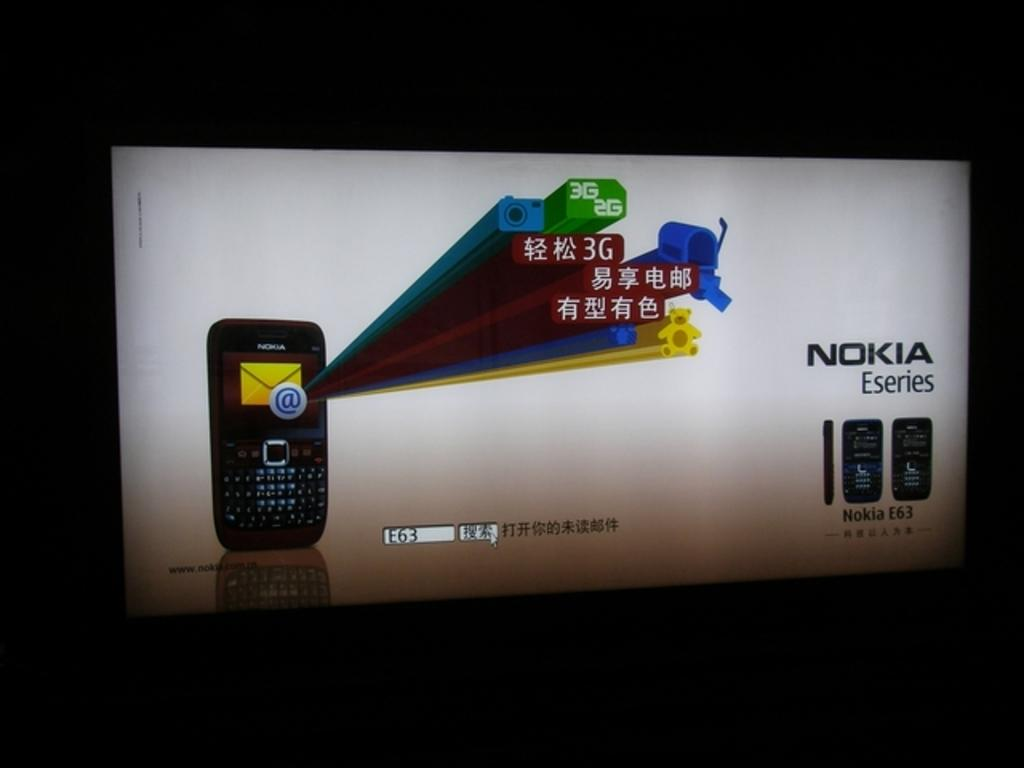<image>
Write a terse but informative summary of the picture. A Nokia Eseries electronic cell phone large advertisement 